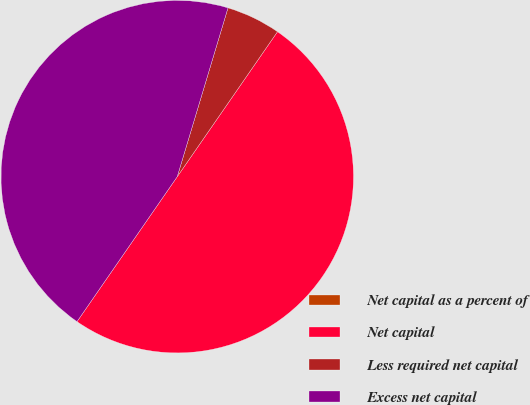<chart> <loc_0><loc_0><loc_500><loc_500><pie_chart><fcel>Net capital as a percent of<fcel>Net capital<fcel>Less required net capital<fcel>Excess net capital<nl><fcel>0.0%<fcel>50.0%<fcel>4.98%<fcel>45.02%<nl></chart> 